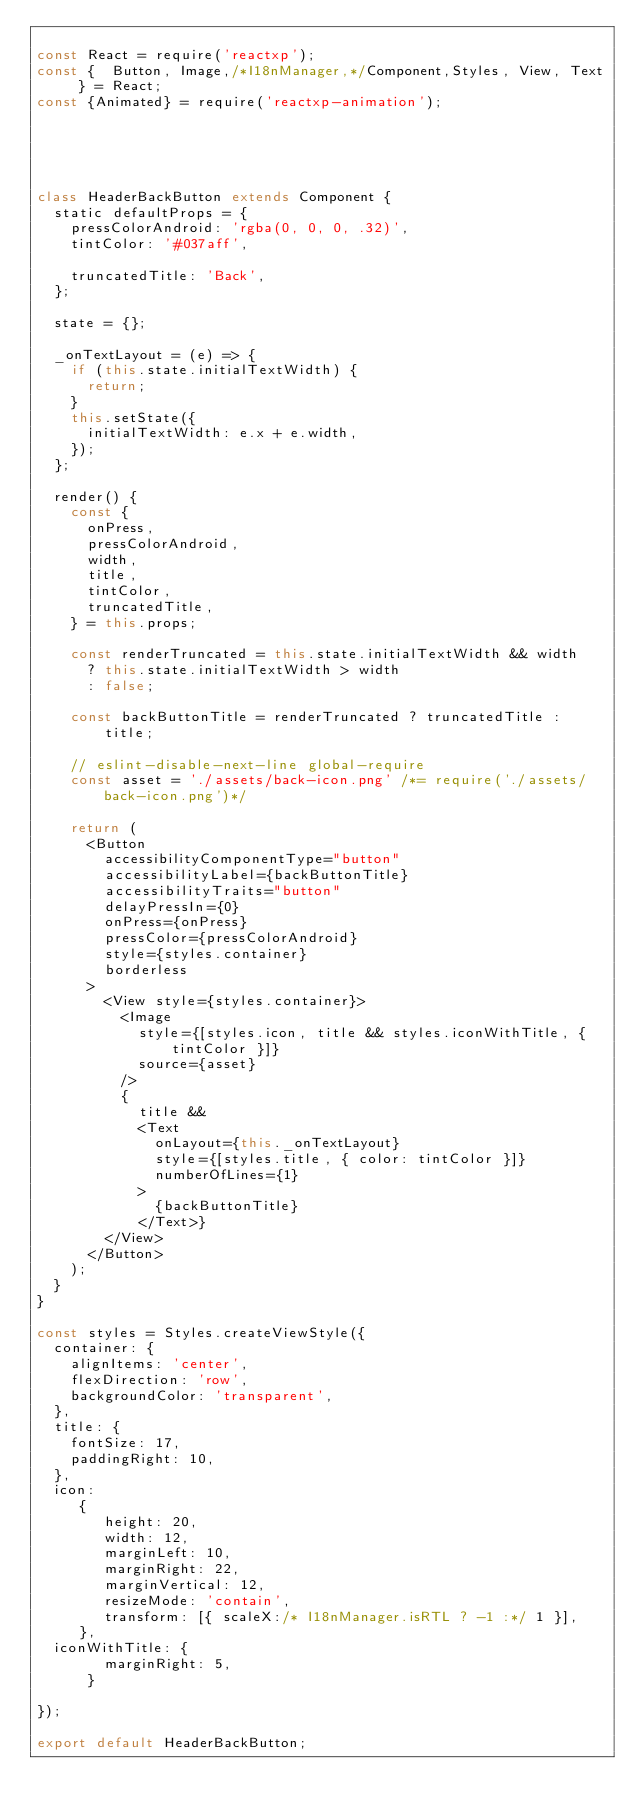Convert code to text. <code><loc_0><loc_0><loc_500><loc_500><_JavaScript_>
const React = require('reactxp');
const {  Button, Image,/*I18nManager,*/Component,Styles, View, Text } = React;
const {Animated} = require('reactxp-animation');





class HeaderBackButton extends Component {
  static defaultProps = {
    pressColorAndroid: 'rgba(0, 0, 0, .32)',
    tintColor: '#037aff',
    
    truncatedTitle: 'Back',
  };

  state = {};

  _onTextLayout = (e) => {
    if (this.state.initialTextWidth) {
      return;
    }
    this.setState({
      initialTextWidth: e.x + e.width,
    });
  };

  render() {
    const {
      onPress,
      pressColorAndroid,
      width,
      title,
      tintColor,
      truncatedTitle,
    } = this.props;

    const renderTruncated = this.state.initialTextWidth && width
      ? this.state.initialTextWidth > width
      : false;

    const backButtonTitle = renderTruncated ? truncatedTitle : title;

    // eslint-disable-next-line global-require
    const asset = './assets/back-icon.png' /*= require('./assets/back-icon.png')*/

    return (
      <Button
        accessibilityComponentType="button"
        accessibilityLabel={backButtonTitle}
        accessibilityTraits="button"
        delayPressIn={0}
        onPress={onPress}
        pressColor={pressColorAndroid}
        style={styles.container}
        borderless
      >
        <View style={styles.container}>
          <Image
            style={[styles.icon, title && styles.iconWithTitle, { tintColor }]}
            source={asset}
          />
          {
            title &&
            <Text
              onLayout={this._onTextLayout}
              style={[styles.title, { color: tintColor }]}
              numberOfLines={1}
            >
              {backButtonTitle}
            </Text>}
        </View>
      </Button>
    );
  }
}

const styles = Styles.createViewStyle({
  container: {
    alignItems: 'center',
    flexDirection: 'row',
    backgroundColor: 'transparent',
  },
  title: {
    fontSize: 17,
    paddingRight: 10,
  },
  icon: 
     {
        height: 20,
        width: 12,
        marginLeft: 10,
        marginRight: 22,
        marginVertical: 12,
        resizeMode: 'contain',
        transform: [{ scaleX:/* I18nManager.isRTL ? -1 :*/ 1 }],
     },
  iconWithTitle: {
        marginRight: 5,
      }
    
});

export default HeaderBackButton;
</code> 